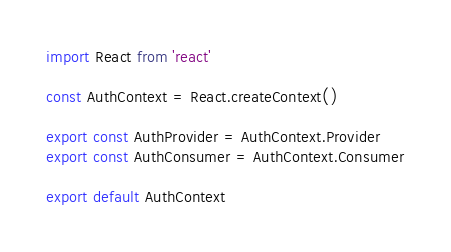Convert code to text. <code><loc_0><loc_0><loc_500><loc_500><_JavaScript_>import React from 'react'

const AuthContext = React.createContext()

export const AuthProvider = AuthContext.Provider
export const AuthConsumer = AuthContext.Consumer

export default AuthContext</code> 